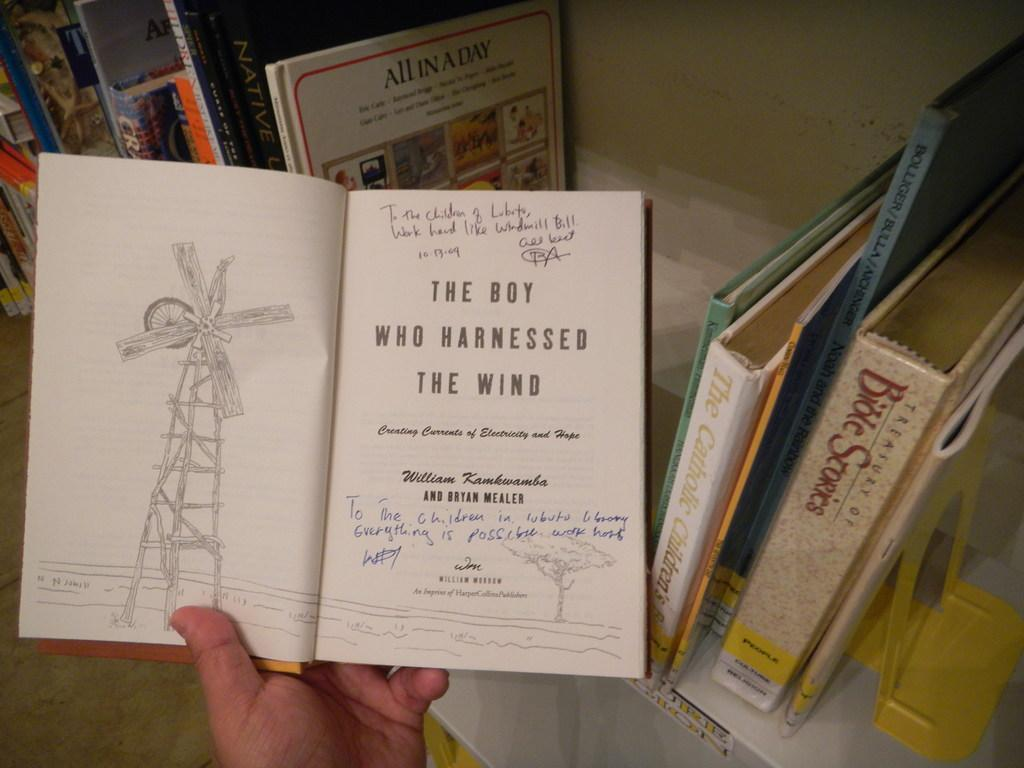<image>
Provide a brief description of the given image. A book autographed by its author is about a boy who harnessed the wind. 